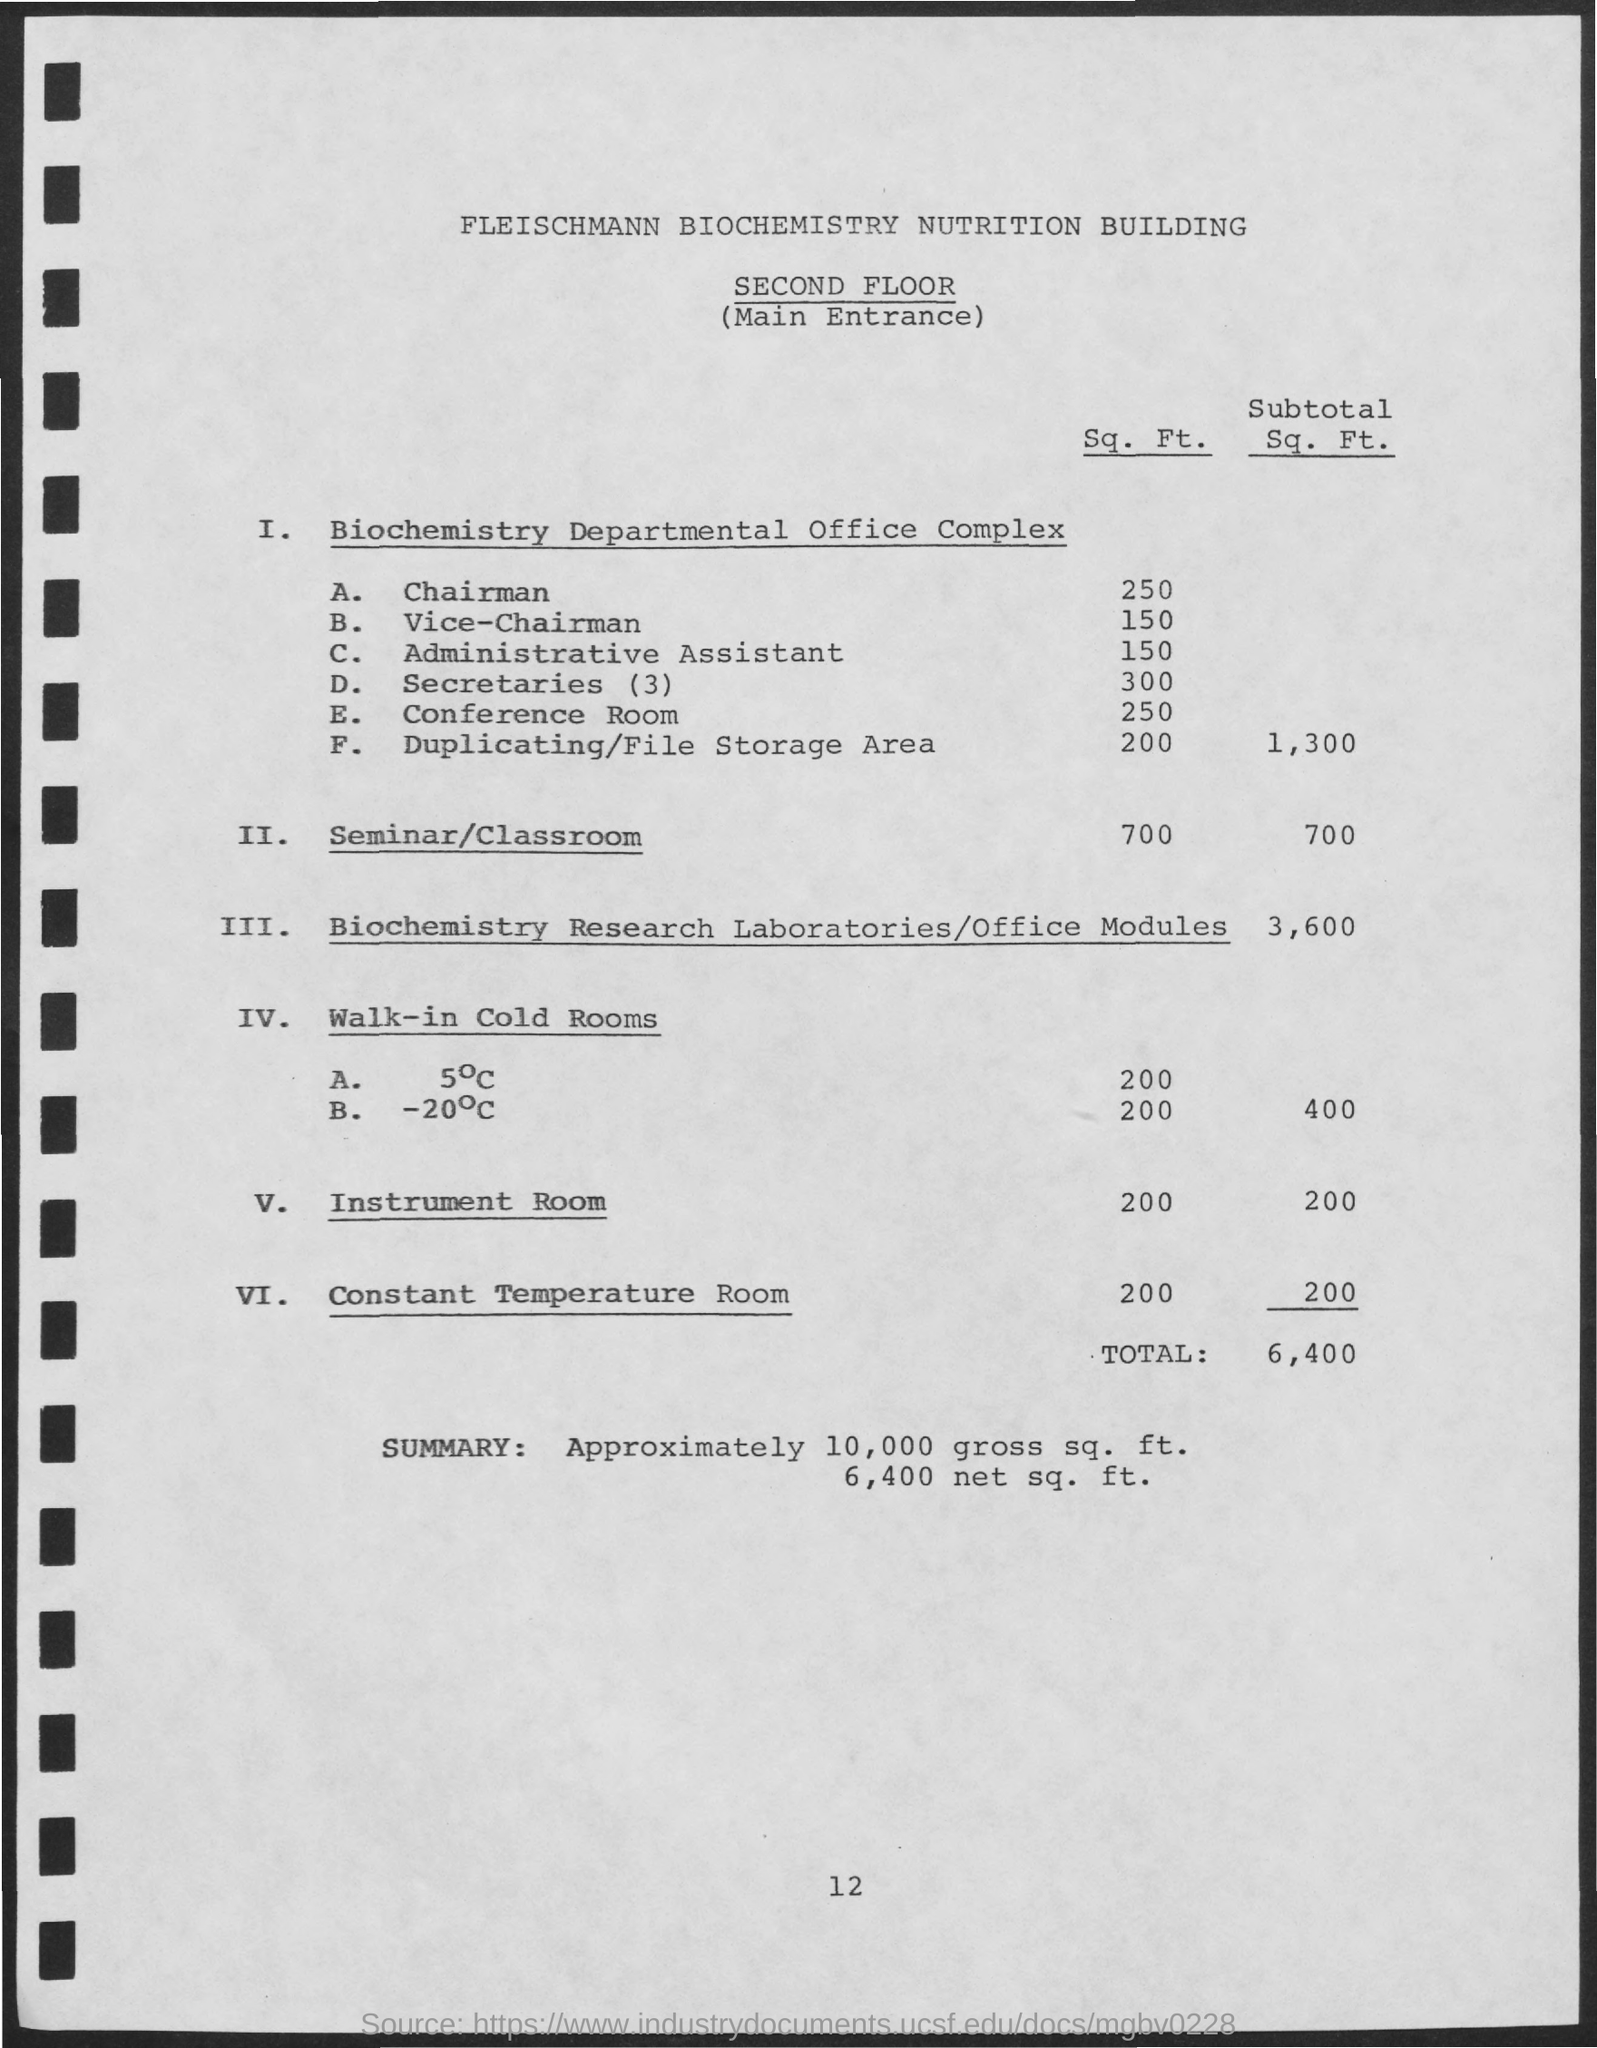What is the sq. ft. value of seminar/ classroom mentioned ?
Provide a short and direct response. 700. What is the subtotal sq. ft. value of biochemistry research laboratories /office modules ?
Make the answer very short. 3,600. What is the sq. ft. value of instrument room mentioned ?
Your response must be concise. 200. What is the total value mentioned ?
Your answer should be very brief. 6,400. 